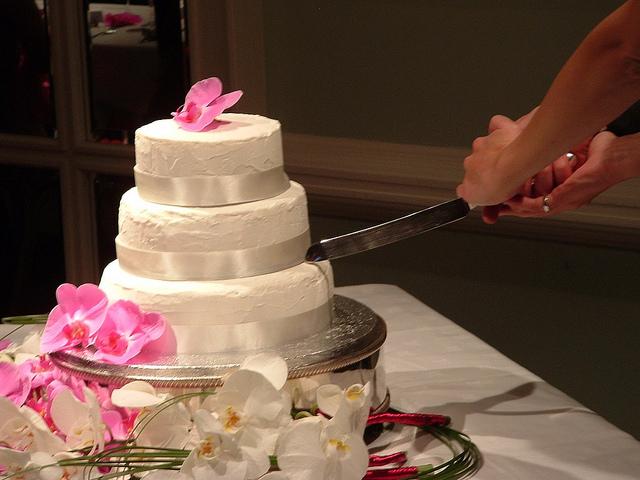Are the rings on the hands gold or silver in color?
Answer briefly. Silver. How many tiers does the cake have?
Short answer required. 3. What event is celebrated here?
Give a very brief answer. Wedding. 